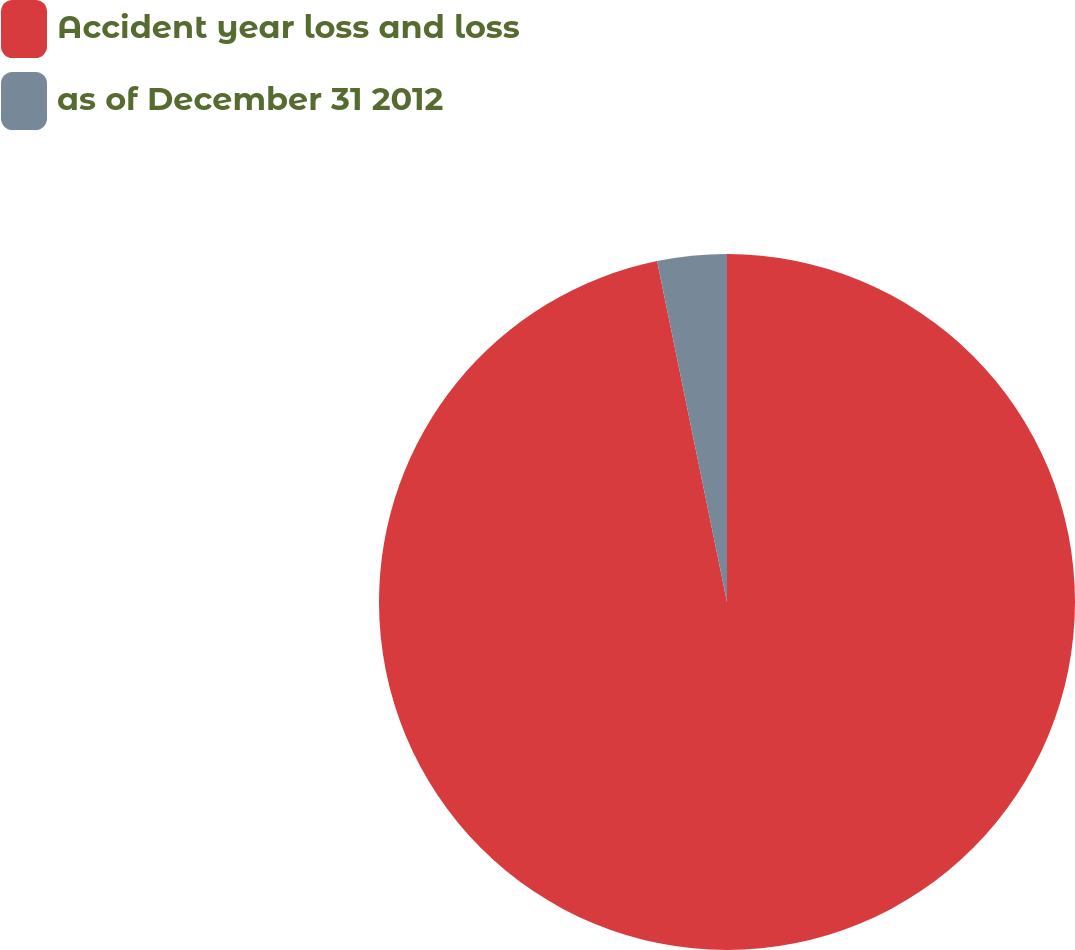Convert chart to OTSL. <chart><loc_0><loc_0><loc_500><loc_500><pie_chart><fcel>Accident year loss and loss<fcel>as of December 31 2012<nl><fcel>96.78%<fcel>3.22%<nl></chart> 